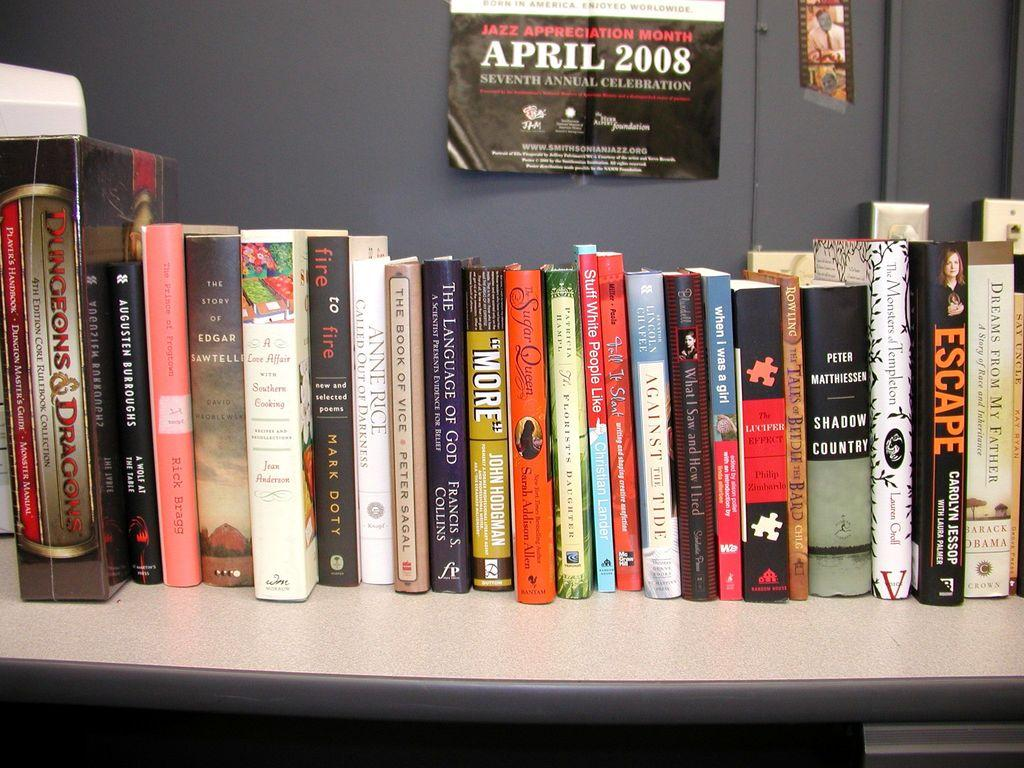Provide a one-sentence caption for the provided image. A bookshelf with a poster advertising the Seventh Annual Jazz Appreciation Month for April 2008. 